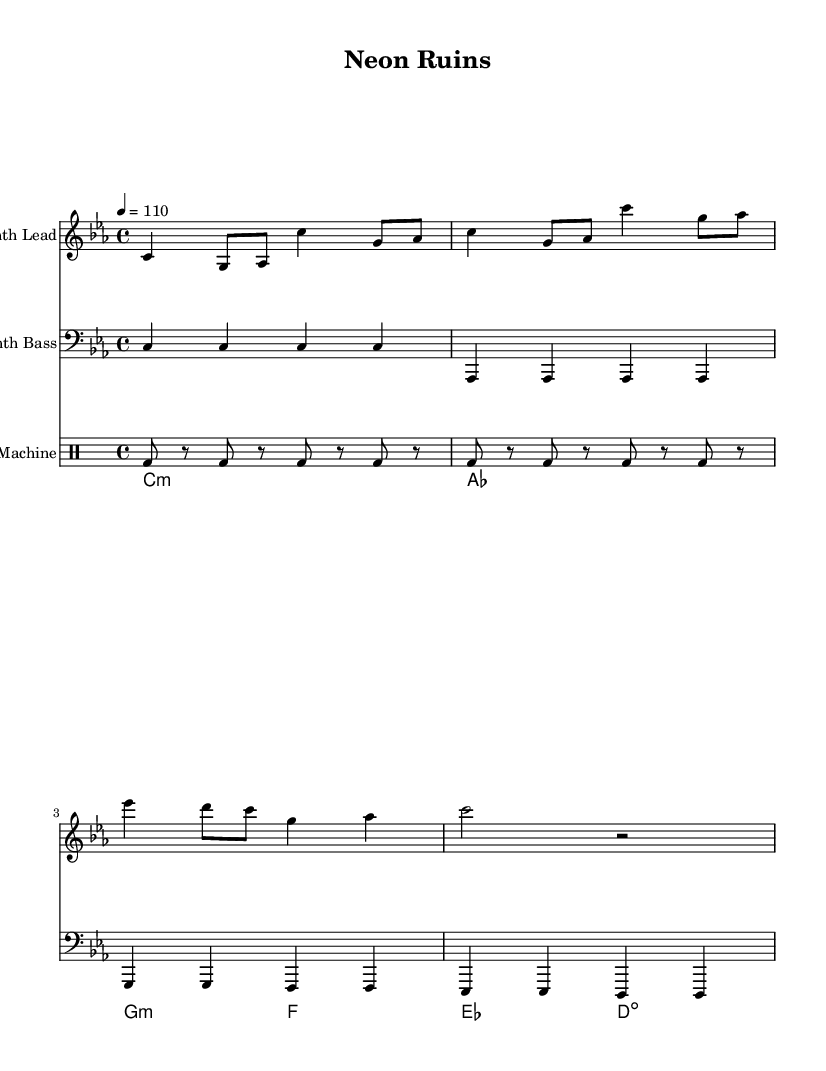What is the key signature of this music? The key signature indicates C minor, which has three flats. You can see the flats represented at the beginning of the staff.
Answer: C minor What is the time signature of the composition? The time signature is found right after the key signature in the sheet music and is indicated as 4/4, meaning there are four beats in each measure.
Answer: 4/4 What is the tempo marking for this piece? The tempo marking appears at the start of the score, shown as "4 = 110," indicating a moderate pace of 110 beats per minute.
Answer: 110 How many measures are present in the Synth Lead section? Counting the measures in the Synth Lead part, there are a total of 4 measures, as indicated by the grouping of notes.
Answer: 4 What type of chord is used in the first measure of Synth Pad? The first measure of the Synth Pad shows a minor chord indicated by "c1:m" signifying a C minor chord.
Answer: C minor Which instrument plays the bass line in this composition? The bass line is specifically designated to be played by the "Synth Bass" part, which is labeled at the beginning of that staff in the music.
Answer: Synth Bass What rhythm pattern is utilized by the Drum Machine? The rhythm pattern can be observed as a steady bass drum hit every eighth note, which is characteristic of electronic music drumming styles.
Answer: Eighth note pattern 